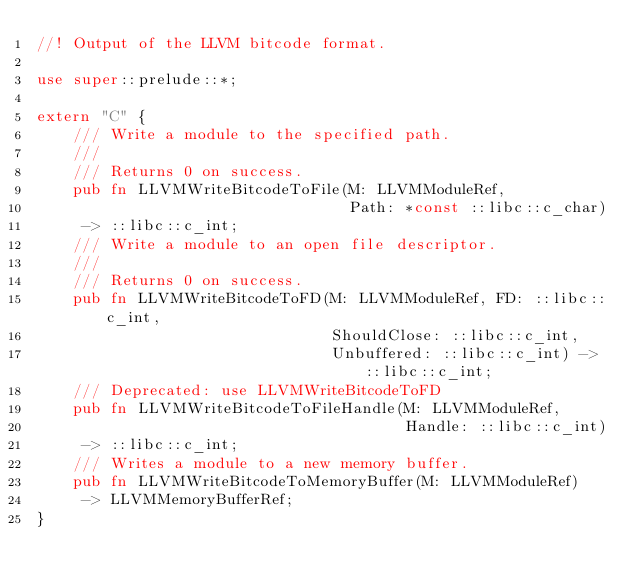Convert code to text. <code><loc_0><loc_0><loc_500><loc_500><_Rust_>//! Output of the LLVM bitcode format.

use super::prelude::*;

extern "C" {
    /// Write a module to the specified path.
    ///
    /// Returns 0 on success.
    pub fn LLVMWriteBitcodeToFile(M: LLVMModuleRef,
                                  Path: *const ::libc::c_char)
     -> ::libc::c_int;
    /// Write a module to an open file descriptor.
    ///
    /// Returns 0 on success.
    pub fn LLVMWriteBitcodeToFD(M: LLVMModuleRef, FD: ::libc::c_int,
                                ShouldClose: ::libc::c_int,
                                Unbuffered: ::libc::c_int) -> ::libc::c_int;
    /// Deprecated: use LLVMWriteBitcodeToFD
    pub fn LLVMWriteBitcodeToFileHandle(M: LLVMModuleRef,
                                        Handle: ::libc::c_int)
     -> ::libc::c_int;
    /// Writes a module to a new memory buffer.
    pub fn LLVMWriteBitcodeToMemoryBuffer(M: LLVMModuleRef)
     -> LLVMMemoryBufferRef;
}
</code> 